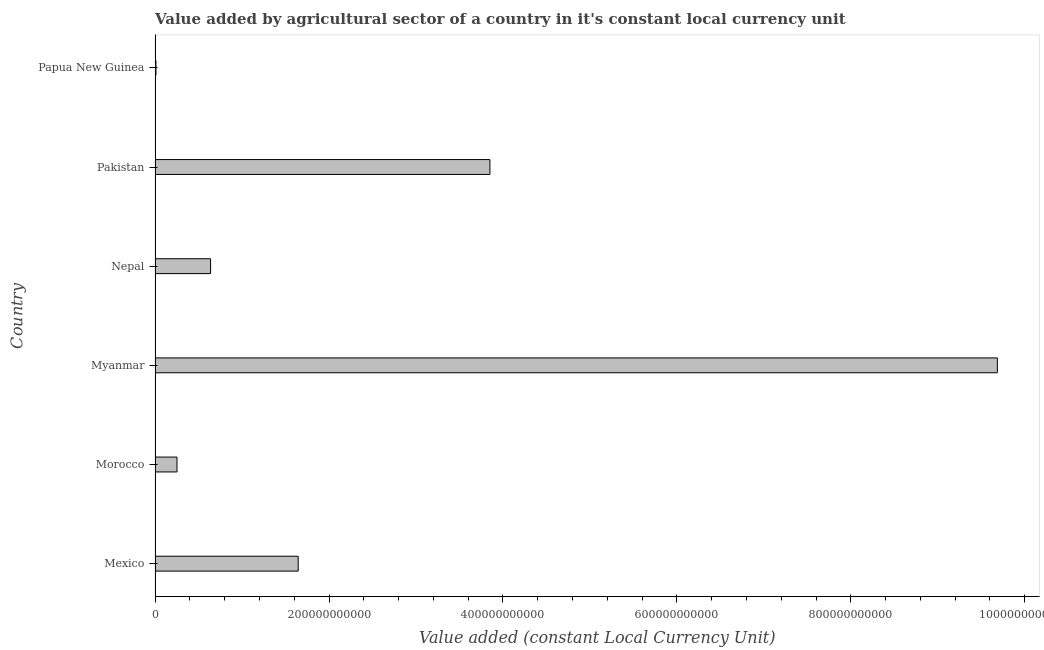Does the graph contain grids?
Provide a succinct answer. No. What is the title of the graph?
Keep it short and to the point. Value added by agricultural sector of a country in it's constant local currency unit. What is the label or title of the X-axis?
Offer a terse response. Value added (constant Local Currency Unit). What is the label or title of the Y-axis?
Your answer should be very brief. Country. What is the value added by agriculture sector in Papua New Guinea?
Your answer should be very brief. 1.05e+09. Across all countries, what is the maximum value added by agriculture sector?
Your answer should be compact. 9.69e+11. Across all countries, what is the minimum value added by agriculture sector?
Your answer should be very brief. 1.05e+09. In which country was the value added by agriculture sector maximum?
Ensure brevity in your answer.  Myanmar. In which country was the value added by agriculture sector minimum?
Provide a short and direct response. Papua New Guinea. What is the sum of the value added by agriculture sector?
Offer a very short reply. 1.61e+12. What is the difference between the value added by agriculture sector in Morocco and Myanmar?
Make the answer very short. -9.43e+11. What is the average value added by agriculture sector per country?
Your response must be concise. 2.68e+11. What is the median value added by agriculture sector?
Make the answer very short. 1.14e+11. What is the ratio of the value added by agriculture sector in Mexico to that in Pakistan?
Provide a short and direct response. 0.43. Is the value added by agriculture sector in Morocco less than that in Nepal?
Ensure brevity in your answer.  Yes. Is the difference between the value added by agriculture sector in Pakistan and Papua New Guinea greater than the difference between any two countries?
Keep it short and to the point. No. What is the difference between the highest and the second highest value added by agriculture sector?
Keep it short and to the point. 5.83e+11. Is the sum of the value added by agriculture sector in Mexico and Papua New Guinea greater than the maximum value added by agriculture sector across all countries?
Ensure brevity in your answer.  No. What is the difference between the highest and the lowest value added by agriculture sector?
Keep it short and to the point. 9.67e+11. In how many countries, is the value added by agriculture sector greater than the average value added by agriculture sector taken over all countries?
Ensure brevity in your answer.  2. Are all the bars in the graph horizontal?
Your answer should be compact. Yes. What is the difference between two consecutive major ticks on the X-axis?
Provide a short and direct response. 2.00e+11. What is the Value added (constant Local Currency Unit) of Mexico?
Keep it short and to the point. 1.65e+11. What is the Value added (constant Local Currency Unit) of Morocco?
Ensure brevity in your answer.  2.52e+1. What is the Value added (constant Local Currency Unit) of Myanmar?
Give a very brief answer. 9.69e+11. What is the Value added (constant Local Currency Unit) in Nepal?
Your answer should be very brief. 6.38e+1. What is the Value added (constant Local Currency Unit) of Pakistan?
Your answer should be compact. 3.85e+11. What is the Value added (constant Local Currency Unit) in Papua New Guinea?
Your response must be concise. 1.05e+09. What is the difference between the Value added (constant Local Currency Unit) in Mexico and Morocco?
Offer a terse response. 1.39e+11. What is the difference between the Value added (constant Local Currency Unit) in Mexico and Myanmar?
Offer a terse response. -8.04e+11. What is the difference between the Value added (constant Local Currency Unit) in Mexico and Nepal?
Ensure brevity in your answer.  1.01e+11. What is the difference between the Value added (constant Local Currency Unit) in Mexico and Pakistan?
Offer a terse response. -2.20e+11. What is the difference between the Value added (constant Local Currency Unit) in Mexico and Papua New Guinea?
Your response must be concise. 1.64e+11. What is the difference between the Value added (constant Local Currency Unit) in Morocco and Myanmar?
Your answer should be compact. -9.43e+11. What is the difference between the Value added (constant Local Currency Unit) in Morocco and Nepal?
Keep it short and to the point. -3.86e+1. What is the difference between the Value added (constant Local Currency Unit) in Morocco and Pakistan?
Make the answer very short. -3.60e+11. What is the difference between the Value added (constant Local Currency Unit) in Morocco and Papua New Guinea?
Keep it short and to the point. 2.42e+1. What is the difference between the Value added (constant Local Currency Unit) in Myanmar and Nepal?
Make the answer very short. 9.05e+11. What is the difference between the Value added (constant Local Currency Unit) in Myanmar and Pakistan?
Provide a short and direct response. 5.83e+11. What is the difference between the Value added (constant Local Currency Unit) in Myanmar and Papua New Guinea?
Keep it short and to the point. 9.67e+11. What is the difference between the Value added (constant Local Currency Unit) in Nepal and Pakistan?
Offer a terse response. -3.21e+11. What is the difference between the Value added (constant Local Currency Unit) in Nepal and Papua New Guinea?
Offer a very short reply. 6.28e+1. What is the difference between the Value added (constant Local Currency Unit) in Pakistan and Papua New Guinea?
Make the answer very short. 3.84e+11. What is the ratio of the Value added (constant Local Currency Unit) in Mexico to that in Morocco?
Make the answer very short. 6.53. What is the ratio of the Value added (constant Local Currency Unit) in Mexico to that in Myanmar?
Offer a terse response. 0.17. What is the ratio of the Value added (constant Local Currency Unit) in Mexico to that in Nepal?
Offer a terse response. 2.58. What is the ratio of the Value added (constant Local Currency Unit) in Mexico to that in Pakistan?
Your response must be concise. 0.43. What is the ratio of the Value added (constant Local Currency Unit) in Mexico to that in Papua New Guinea?
Ensure brevity in your answer.  157.23. What is the ratio of the Value added (constant Local Currency Unit) in Morocco to that in Myanmar?
Provide a succinct answer. 0.03. What is the ratio of the Value added (constant Local Currency Unit) in Morocco to that in Nepal?
Offer a terse response. 0.4. What is the ratio of the Value added (constant Local Currency Unit) in Morocco to that in Pakistan?
Offer a very short reply. 0.07. What is the ratio of the Value added (constant Local Currency Unit) in Morocco to that in Papua New Guinea?
Your answer should be very brief. 24.08. What is the ratio of the Value added (constant Local Currency Unit) in Myanmar to that in Nepal?
Your response must be concise. 15.17. What is the ratio of the Value added (constant Local Currency Unit) in Myanmar to that in Pakistan?
Make the answer very short. 2.52. What is the ratio of the Value added (constant Local Currency Unit) in Myanmar to that in Papua New Guinea?
Make the answer very short. 925.29. What is the ratio of the Value added (constant Local Currency Unit) in Nepal to that in Pakistan?
Offer a terse response. 0.17. What is the ratio of the Value added (constant Local Currency Unit) in Nepal to that in Papua New Guinea?
Make the answer very short. 60.98. What is the ratio of the Value added (constant Local Currency Unit) in Pakistan to that in Papua New Guinea?
Provide a succinct answer. 367.84. 